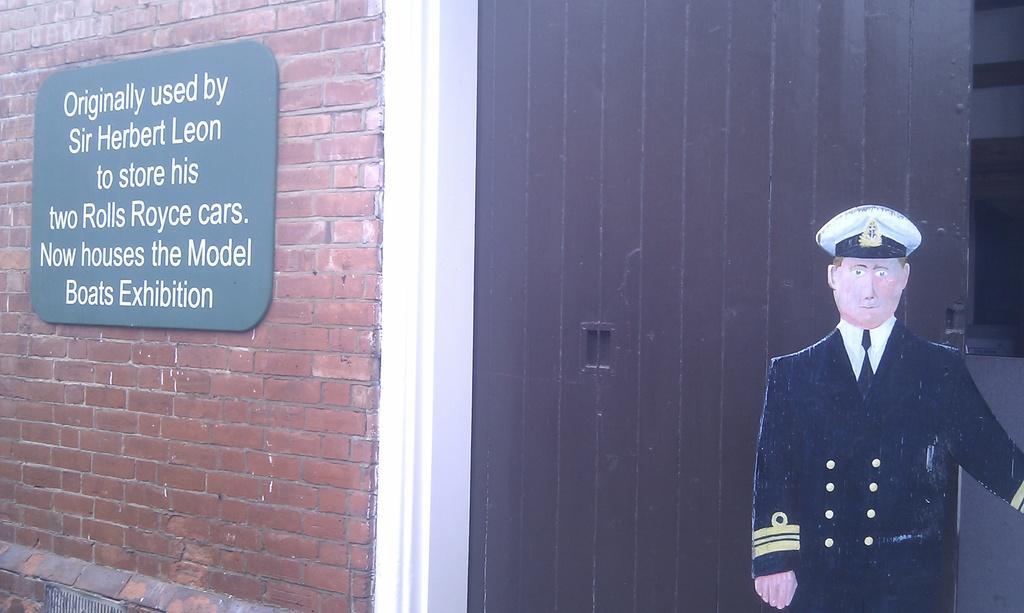Can you describe this image briefly? This is the board, which is attached to the wall. This looks like a wooden door. I can see the cut out of the man standing with uniform. This wall is of brick texture. 